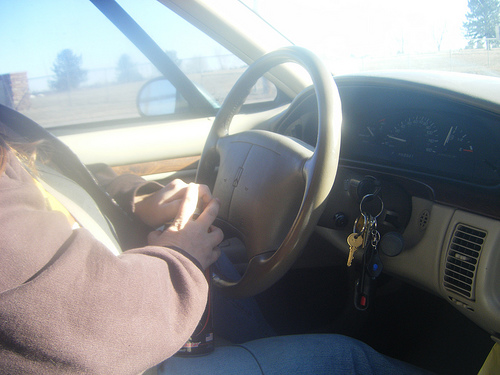<image>
Is the car behind the man? No. The car is not behind the man. From this viewpoint, the car appears to be positioned elsewhere in the scene. 